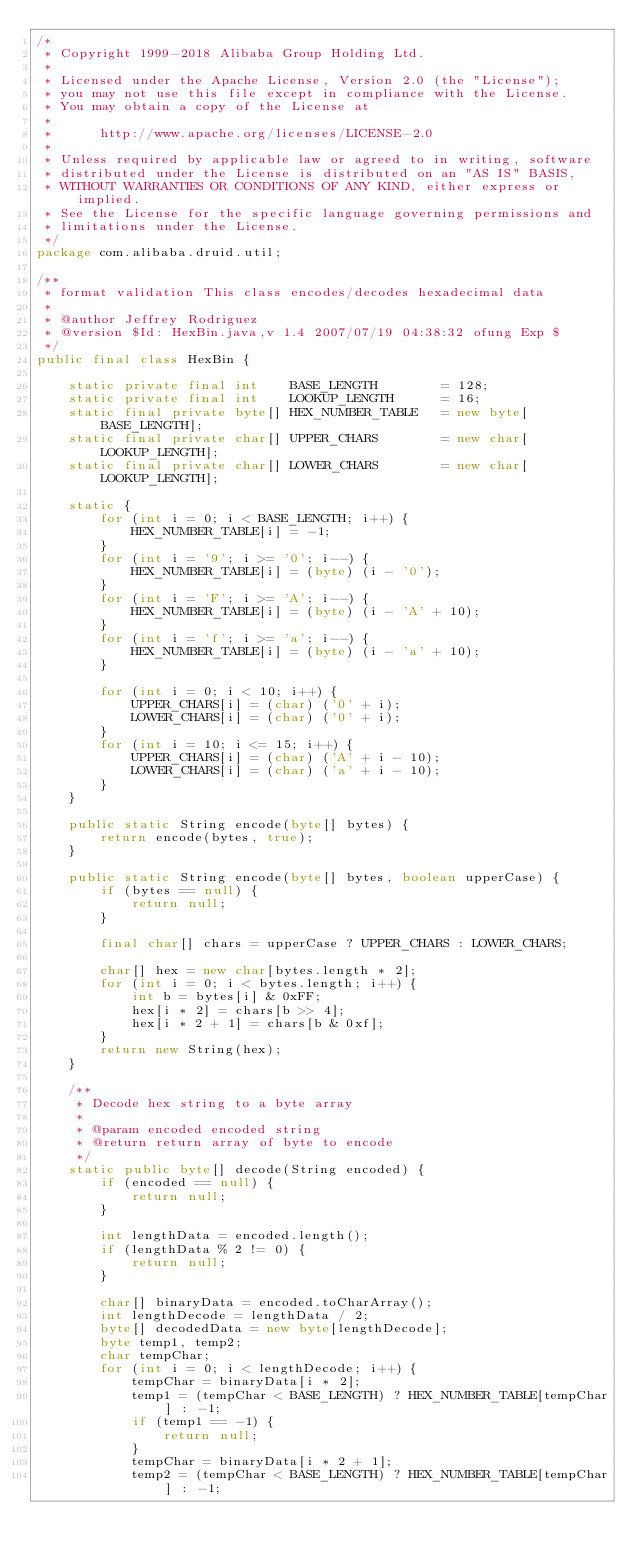Convert code to text. <code><loc_0><loc_0><loc_500><loc_500><_Java_>/*
 * Copyright 1999-2018 Alibaba Group Holding Ltd.
 *
 * Licensed under the Apache License, Version 2.0 (the "License");
 * you may not use this file except in compliance with the License.
 * You may obtain a copy of the License at
 *
 *      http://www.apache.org/licenses/LICENSE-2.0
 *
 * Unless required by applicable law or agreed to in writing, software
 * distributed under the License is distributed on an "AS IS" BASIS,
 * WITHOUT WARRANTIES OR CONDITIONS OF ANY KIND, either express or implied.
 * See the License for the specific language governing permissions and
 * limitations under the License.
 */
package com.alibaba.druid.util;

/**
 * format validation This class encodes/decodes hexadecimal data
 * 
 * @author Jeffrey Rodriguez
 * @version $Id: HexBin.java,v 1.4 2007/07/19 04:38:32 ofung Exp $
 */
public final class HexBin {

    static private final int    BASE_LENGTH        = 128;
    static private final int    LOOKUP_LENGTH      = 16;
    static final private byte[] HEX_NUMBER_TABLE   = new byte[BASE_LENGTH];
    static final private char[] UPPER_CHARS        = new char[LOOKUP_LENGTH];
    static final private char[] LOWER_CHARS        = new char[LOOKUP_LENGTH];

    static {
        for (int i = 0; i < BASE_LENGTH; i++) {
            HEX_NUMBER_TABLE[i] = -1;
        }
        for (int i = '9'; i >= '0'; i--) {
            HEX_NUMBER_TABLE[i] = (byte) (i - '0');
        }
        for (int i = 'F'; i >= 'A'; i--) {
            HEX_NUMBER_TABLE[i] = (byte) (i - 'A' + 10);
        }
        for (int i = 'f'; i >= 'a'; i--) {
            HEX_NUMBER_TABLE[i] = (byte) (i - 'a' + 10);
        }

        for (int i = 0; i < 10; i++) {
            UPPER_CHARS[i] = (char) ('0' + i);
            LOWER_CHARS[i] = (char) ('0' + i);
        }
        for (int i = 10; i <= 15; i++) {
            UPPER_CHARS[i] = (char) ('A' + i - 10);
            LOWER_CHARS[i] = (char) ('a' + i - 10);
        }
    }
    
    public static String encode(byte[] bytes) {
        return encode(bytes, true);
    }

    public static String encode(byte[] bytes, boolean upperCase) {
        if (bytes == null) {
            return null;
        }

        final char[] chars = upperCase ? UPPER_CHARS : LOWER_CHARS;

        char[] hex = new char[bytes.length * 2];
        for (int i = 0; i < bytes.length; i++) {
            int b = bytes[i] & 0xFF;
            hex[i * 2] = chars[b >> 4];
            hex[i * 2 + 1] = chars[b & 0xf];
        }
        return new String(hex);
    }

    /**
     * Decode hex string to a byte array
     * 
     * @param encoded encoded string
     * @return return array of byte to encode
     */
    static public byte[] decode(String encoded) {
        if (encoded == null) {
            return null;
        }

        int lengthData = encoded.length();
        if (lengthData % 2 != 0) {
            return null;
        }

        char[] binaryData = encoded.toCharArray();
        int lengthDecode = lengthData / 2;
        byte[] decodedData = new byte[lengthDecode];
        byte temp1, temp2;
        char tempChar;
        for (int i = 0; i < lengthDecode; i++) {
            tempChar = binaryData[i * 2];
            temp1 = (tempChar < BASE_LENGTH) ? HEX_NUMBER_TABLE[tempChar] : -1;
            if (temp1 == -1) {
                return null;
            }
            tempChar = binaryData[i * 2 + 1];
            temp2 = (tempChar < BASE_LENGTH) ? HEX_NUMBER_TABLE[tempChar] : -1;</code> 